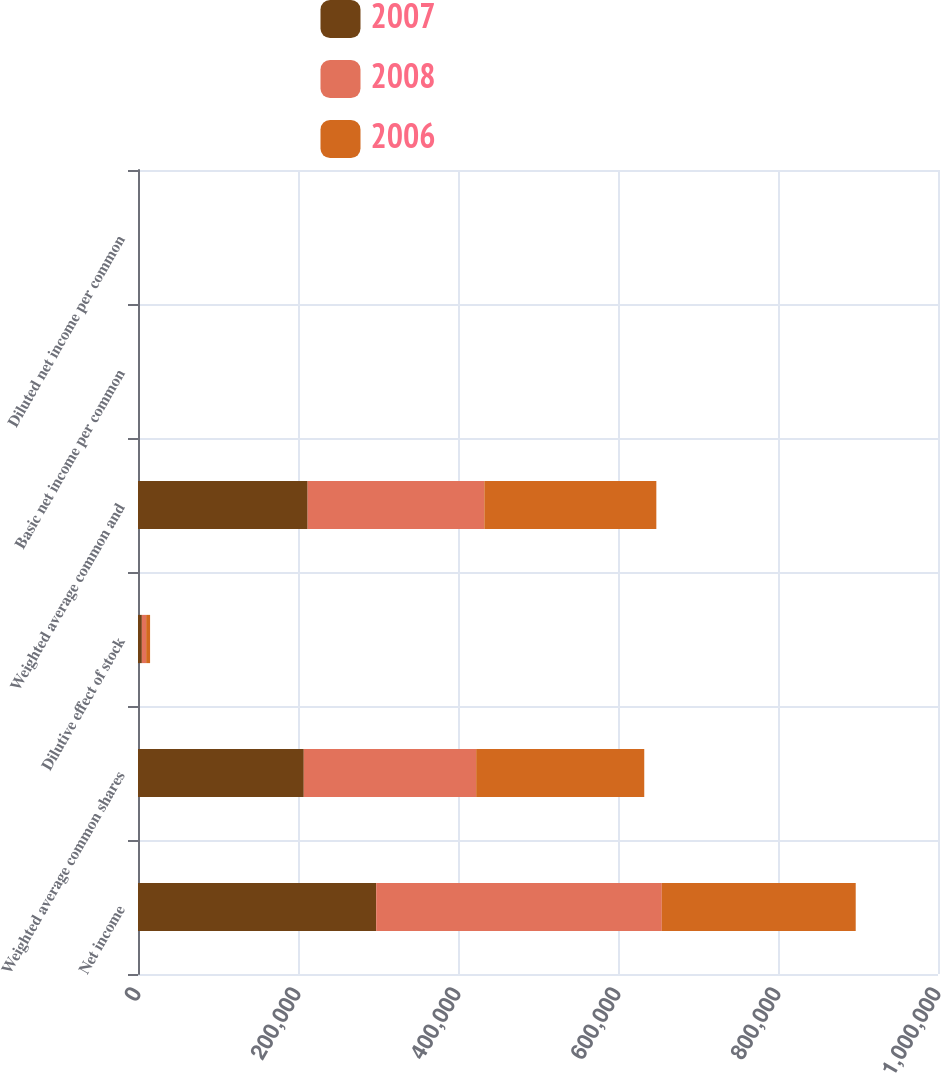Convert chart to OTSL. <chart><loc_0><loc_0><loc_500><loc_500><stacked_bar_chart><ecel><fcel>Net income<fcel>Weighted average common shares<fcel>Dilutive effect of stock<fcel>Weighted average common and<fcel>Basic net income per common<fcel>Diluted net income per common<nl><fcel>2007<fcel>297748<fcel>207220<fcel>4828<fcel>212048<fcel>1.44<fcel>1.4<nl><fcel>2008<fcel>357029<fcel>215498<fcel>5350<fcel>220848<fcel>1.66<fcel>1.62<nl><fcel>2006<fcel>242369<fcel>210104<fcel>4920<fcel>215024<fcel>1.15<fcel>1.13<nl></chart> 